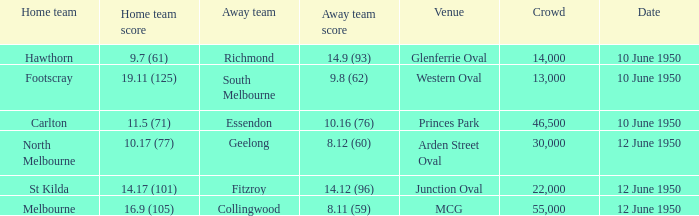What was the crowd when Melbourne was the home team? 55000.0. 